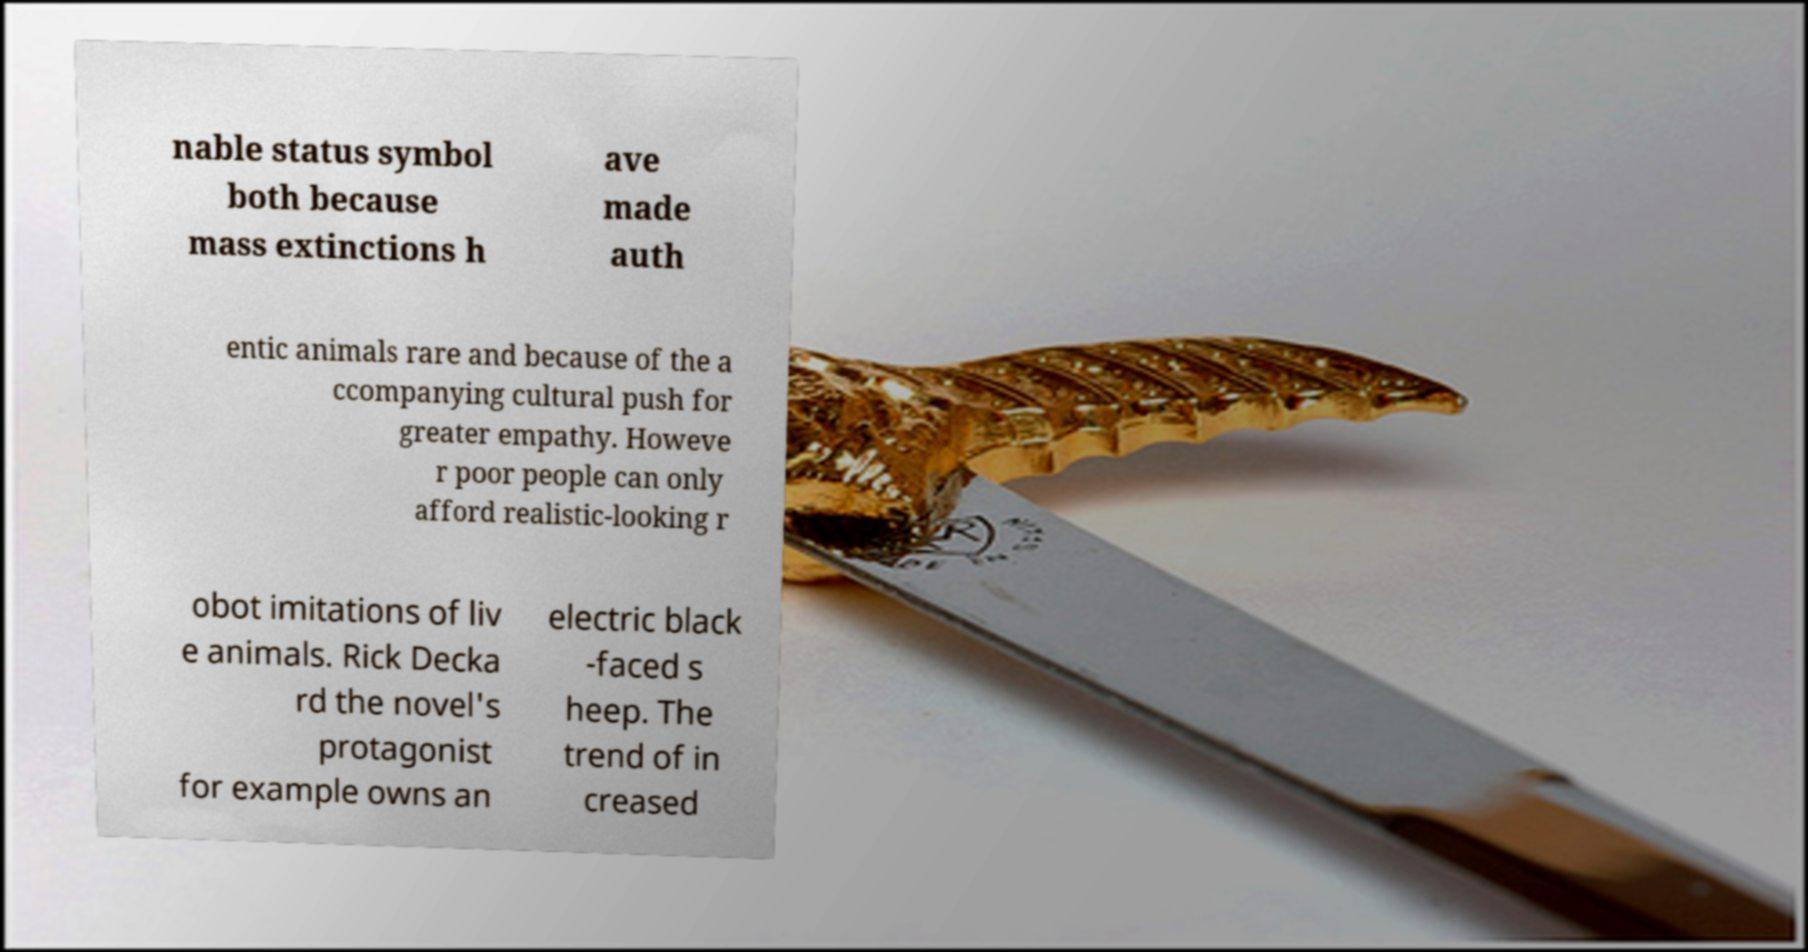Could you extract and type out the text from this image? nable status symbol both because mass extinctions h ave made auth entic animals rare and because of the a ccompanying cultural push for greater empathy. Howeve r poor people can only afford realistic-looking r obot imitations of liv e animals. Rick Decka rd the novel's protagonist for example owns an electric black -faced s heep. The trend of in creased 